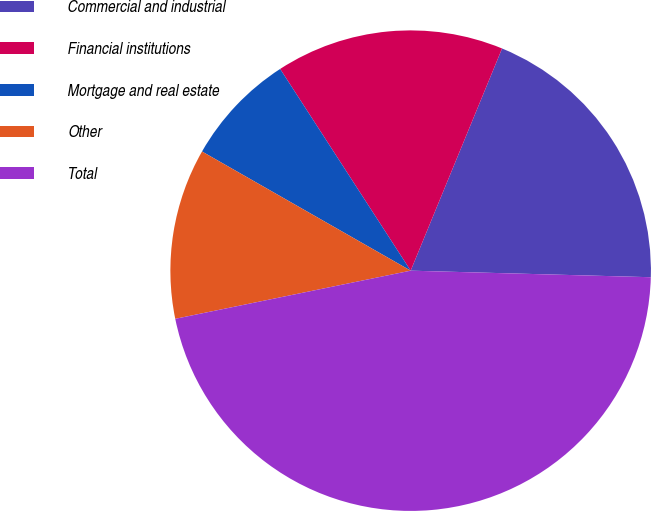Convert chart to OTSL. <chart><loc_0><loc_0><loc_500><loc_500><pie_chart><fcel>Commercial and industrial<fcel>Financial institutions<fcel>Mortgage and real estate<fcel>Other<fcel>Total<nl><fcel>19.22%<fcel>15.35%<fcel>7.6%<fcel>11.47%<fcel>46.35%<nl></chart> 